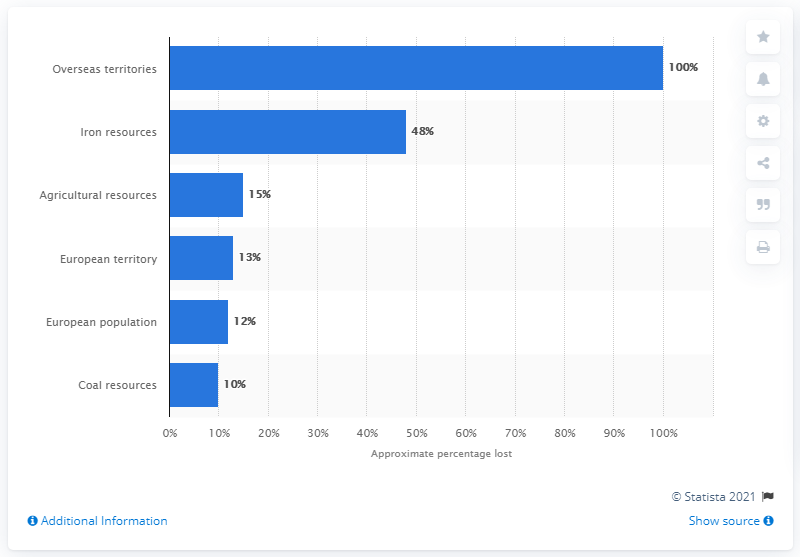Mention a couple of crucial points in this snapshot. Germany lost approximately 48 million metric tons of iron output during the First World War. 